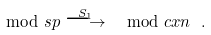Convert formula to latex. <formula><loc_0><loc_0><loc_500><loc_500>\mod s p \overset { S _ { 1 } } { \longrightarrow } \mod c x n \ .</formula> 